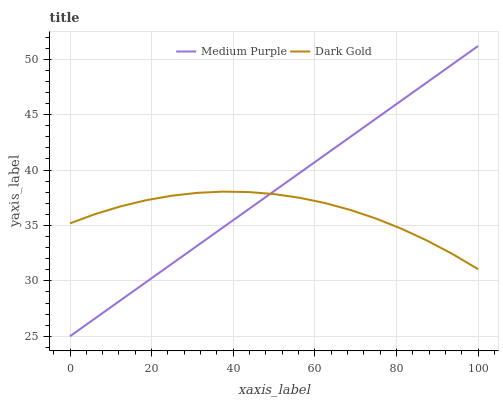Does Dark Gold have the maximum area under the curve?
Answer yes or no. No. Is Dark Gold the smoothest?
Answer yes or no. No. Does Dark Gold have the lowest value?
Answer yes or no. No. Does Dark Gold have the highest value?
Answer yes or no. No. 